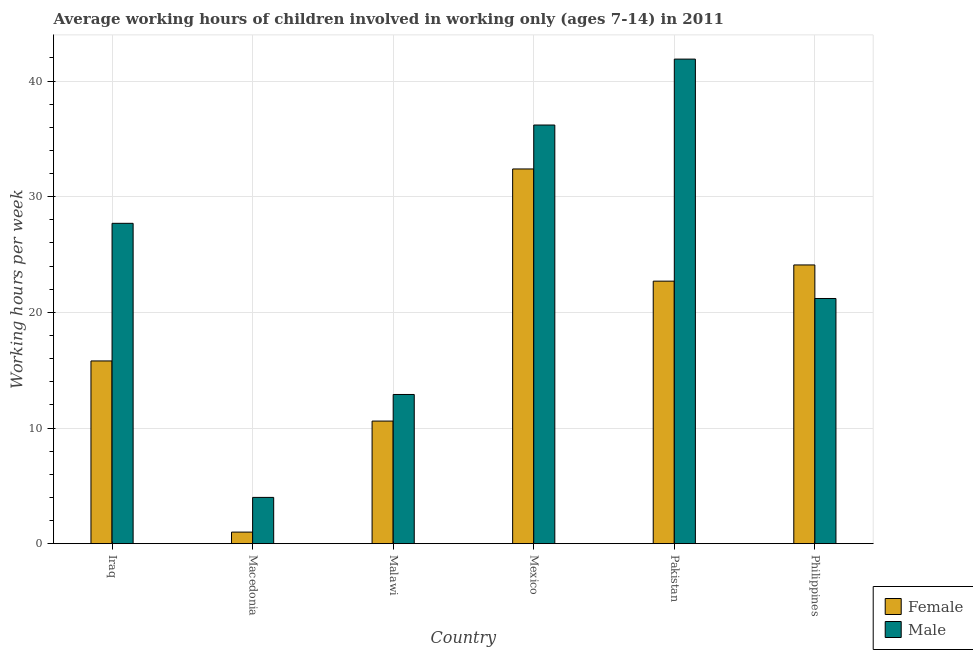How many different coloured bars are there?
Provide a short and direct response. 2. How many groups of bars are there?
Keep it short and to the point. 6. Are the number of bars per tick equal to the number of legend labels?
Your answer should be very brief. Yes. What is the label of the 3rd group of bars from the left?
Make the answer very short. Malawi. What is the average working hour of female children in Malawi?
Keep it short and to the point. 10.6. Across all countries, what is the maximum average working hour of female children?
Ensure brevity in your answer.  32.4. Across all countries, what is the minimum average working hour of male children?
Your answer should be compact. 4. In which country was the average working hour of female children minimum?
Offer a very short reply. Macedonia. What is the total average working hour of female children in the graph?
Give a very brief answer. 106.6. What is the difference between the average working hour of male children in Iraq and that in Philippines?
Offer a terse response. 6.5. What is the difference between the average working hour of male children in Malawi and the average working hour of female children in Iraq?
Your answer should be compact. -2.9. What is the average average working hour of male children per country?
Offer a very short reply. 23.98. What is the difference between the average working hour of male children and average working hour of female children in Philippines?
Provide a short and direct response. -2.9. In how many countries, is the average working hour of female children greater than 20 hours?
Provide a succinct answer. 3. What is the ratio of the average working hour of male children in Macedonia to that in Mexico?
Ensure brevity in your answer.  0.11. Is the average working hour of female children in Mexico less than that in Pakistan?
Keep it short and to the point. No. What is the difference between the highest and the second highest average working hour of female children?
Provide a short and direct response. 8.3. What is the difference between the highest and the lowest average working hour of male children?
Offer a very short reply. 37.9. Is the sum of the average working hour of female children in Iraq and Philippines greater than the maximum average working hour of male children across all countries?
Make the answer very short. No. What does the 2nd bar from the left in Pakistan represents?
Make the answer very short. Male. What does the 1st bar from the right in Iraq represents?
Offer a very short reply. Male. How many bars are there?
Your answer should be very brief. 12. How many countries are there in the graph?
Your response must be concise. 6. What is the difference between two consecutive major ticks on the Y-axis?
Provide a succinct answer. 10. Does the graph contain any zero values?
Your response must be concise. No. Where does the legend appear in the graph?
Your answer should be compact. Bottom right. How are the legend labels stacked?
Offer a very short reply. Vertical. What is the title of the graph?
Your answer should be compact. Average working hours of children involved in working only (ages 7-14) in 2011. What is the label or title of the X-axis?
Provide a succinct answer. Country. What is the label or title of the Y-axis?
Your answer should be compact. Working hours per week. What is the Working hours per week of Male in Iraq?
Provide a short and direct response. 27.7. What is the Working hours per week of Female in Macedonia?
Make the answer very short. 1. What is the Working hours per week in Male in Macedonia?
Provide a short and direct response. 4. What is the Working hours per week of Female in Malawi?
Your answer should be very brief. 10.6. What is the Working hours per week in Female in Mexico?
Ensure brevity in your answer.  32.4. What is the Working hours per week of Male in Mexico?
Your answer should be compact. 36.2. What is the Working hours per week in Female in Pakistan?
Offer a very short reply. 22.7. What is the Working hours per week of Male in Pakistan?
Your answer should be very brief. 41.9. What is the Working hours per week of Female in Philippines?
Offer a terse response. 24.1. What is the Working hours per week of Male in Philippines?
Your response must be concise. 21.2. Across all countries, what is the maximum Working hours per week in Female?
Offer a very short reply. 32.4. Across all countries, what is the maximum Working hours per week of Male?
Provide a succinct answer. 41.9. Across all countries, what is the minimum Working hours per week in Female?
Make the answer very short. 1. Across all countries, what is the minimum Working hours per week in Male?
Keep it short and to the point. 4. What is the total Working hours per week of Female in the graph?
Provide a short and direct response. 106.6. What is the total Working hours per week of Male in the graph?
Give a very brief answer. 143.9. What is the difference between the Working hours per week in Female in Iraq and that in Macedonia?
Provide a short and direct response. 14.8. What is the difference between the Working hours per week in Male in Iraq and that in Macedonia?
Make the answer very short. 23.7. What is the difference between the Working hours per week of Female in Iraq and that in Malawi?
Give a very brief answer. 5.2. What is the difference between the Working hours per week of Female in Iraq and that in Mexico?
Offer a terse response. -16.6. What is the difference between the Working hours per week in Female in Iraq and that in Pakistan?
Provide a short and direct response. -6.9. What is the difference between the Working hours per week of Male in Iraq and that in Philippines?
Your response must be concise. 6.5. What is the difference between the Working hours per week of Female in Macedonia and that in Malawi?
Provide a short and direct response. -9.6. What is the difference between the Working hours per week in Female in Macedonia and that in Mexico?
Your answer should be compact. -31.4. What is the difference between the Working hours per week of Male in Macedonia and that in Mexico?
Provide a short and direct response. -32.2. What is the difference between the Working hours per week of Female in Macedonia and that in Pakistan?
Give a very brief answer. -21.7. What is the difference between the Working hours per week of Male in Macedonia and that in Pakistan?
Make the answer very short. -37.9. What is the difference between the Working hours per week of Female in Macedonia and that in Philippines?
Offer a very short reply. -23.1. What is the difference between the Working hours per week of Male in Macedonia and that in Philippines?
Offer a very short reply. -17.2. What is the difference between the Working hours per week of Female in Malawi and that in Mexico?
Give a very brief answer. -21.8. What is the difference between the Working hours per week of Male in Malawi and that in Mexico?
Keep it short and to the point. -23.3. What is the difference between the Working hours per week of Female in Malawi and that in Pakistan?
Your answer should be very brief. -12.1. What is the difference between the Working hours per week of Male in Malawi and that in Pakistan?
Ensure brevity in your answer.  -29. What is the difference between the Working hours per week in Female in Malawi and that in Philippines?
Keep it short and to the point. -13.5. What is the difference between the Working hours per week of Female in Mexico and that in Philippines?
Your answer should be compact. 8.3. What is the difference between the Working hours per week of Female in Pakistan and that in Philippines?
Your answer should be compact. -1.4. What is the difference between the Working hours per week of Male in Pakistan and that in Philippines?
Offer a very short reply. 20.7. What is the difference between the Working hours per week of Female in Iraq and the Working hours per week of Male in Malawi?
Make the answer very short. 2.9. What is the difference between the Working hours per week of Female in Iraq and the Working hours per week of Male in Mexico?
Your answer should be compact. -20.4. What is the difference between the Working hours per week in Female in Iraq and the Working hours per week in Male in Pakistan?
Offer a terse response. -26.1. What is the difference between the Working hours per week of Female in Macedonia and the Working hours per week of Male in Mexico?
Give a very brief answer. -35.2. What is the difference between the Working hours per week in Female in Macedonia and the Working hours per week in Male in Pakistan?
Your answer should be very brief. -40.9. What is the difference between the Working hours per week in Female in Macedonia and the Working hours per week in Male in Philippines?
Ensure brevity in your answer.  -20.2. What is the difference between the Working hours per week of Female in Malawi and the Working hours per week of Male in Mexico?
Your response must be concise. -25.6. What is the difference between the Working hours per week in Female in Malawi and the Working hours per week in Male in Pakistan?
Provide a short and direct response. -31.3. What is the difference between the Working hours per week of Female in Malawi and the Working hours per week of Male in Philippines?
Offer a very short reply. -10.6. What is the difference between the Working hours per week in Female in Mexico and the Working hours per week in Male in Pakistan?
Provide a succinct answer. -9.5. What is the average Working hours per week of Female per country?
Make the answer very short. 17.77. What is the average Working hours per week in Male per country?
Offer a very short reply. 23.98. What is the difference between the Working hours per week in Female and Working hours per week in Male in Iraq?
Provide a succinct answer. -11.9. What is the difference between the Working hours per week of Female and Working hours per week of Male in Malawi?
Provide a short and direct response. -2.3. What is the difference between the Working hours per week of Female and Working hours per week of Male in Pakistan?
Offer a terse response. -19.2. What is the ratio of the Working hours per week of Female in Iraq to that in Macedonia?
Provide a short and direct response. 15.8. What is the ratio of the Working hours per week of Male in Iraq to that in Macedonia?
Make the answer very short. 6.92. What is the ratio of the Working hours per week of Female in Iraq to that in Malawi?
Provide a short and direct response. 1.49. What is the ratio of the Working hours per week in Male in Iraq to that in Malawi?
Give a very brief answer. 2.15. What is the ratio of the Working hours per week of Female in Iraq to that in Mexico?
Make the answer very short. 0.49. What is the ratio of the Working hours per week of Male in Iraq to that in Mexico?
Keep it short and to the point. 0.77. What is the ratio of the Working hours per week in Female in Iraq to that in Pakistan?
Provide a succinct answer. 0.7. What is the ratio of the Working hours per week of Male in Iraq to that in Pakistan?
Your answer should be very brief. 0.66. What is the ratio of the Working hours per week of Female in Iraq to that in Philippines?
Make the answer very short. 0.66. What is the ratio of the Working hours per week of Male in Iraq to that in Philippines?
Give a very brief answer. 1.31. What is the ratio of the Working hours per week in Female in Macedonia to that in Malawi?
Keep it short and to the point. 0.09. What is the ratio of the Working hours per week in Male in Macedonia to that in Malawi?
Your answer should be very brief. 0.31. What is the ratio of the Working hours per week of Female in Macedonia to that in Mexico?
Give a very brief answer. 0.03. What is the ratio of the Working hours per week of Male in Macedonia to that in Mexico?
Provide a succinct answer. 0.11. What is the ratio of the Working hours per week in Female in Macedonia to that in Pakistan?
Make the answer very short. 0.04. What is the ratio of the Working hours per week of Male in Macedonia to that in Pakistan?
Your answer should be compact. 0.1. What is the ratio of the Working hours per week in Female in Macedonia to that in Philippines?
Your answer should be compact. 0.04. What is the ratio of the Working hours per week of Male in Macedonia to that in Philippines?
Your response must be concise. 0.19. What is the ratio of the Working hours per week of Female in Malawi to that in Mexico?
Provide a succinct answer. 0.33. What is the ratio of the Working hours per week in Male in Malawi to that in Mexico?
Provide a succinct answer. 0.36. What is the ratio of the Working hours per week in Female in Malawi to that in Pakistan?
Your answer should be very brief. 0.47. What is the ratio of the Working hours per week of Male in Malawi to that in Pakistan?
Make the answer very short. 0.31. What is the ratio of the Working hours per week in Female in Malawi to that in Philippines?
Ensure brevity in your answer.  0.44. What is the ratio of the Working hours per week of Male in Malawi to that in Philippines?
Ensure brevity in your answer.  0.61. What is the ratio of the Working hours per week in Female in Mexico to that in Pakistan?
Provide a short and direct response. 1.43. What is the ratio of the Working hours per week of Male in Mexico to that in Pakistan?
Your answer should be compact. 0.86. What is the ratio of the Working hours per week in Female in Mexico to that in Philippines?
Make the answer very short. 1.34. What is the ratio of the Working hours per week of Male in Mexico to that in Philippines?
Provide a short and direct response. 1.71. What is the ratio of the Working hours per week of Female in Pakistan to that in Philippines?
Offer a very short reply. 0.94. What is the ratio of the Working hours per week in Male in Pakistan to that in Philippines?
Provide a short and direct response. 1.98. What is the difference between the highest and the second highest Working hours per week of Female?
Give a very brief answer. 8.3. What is the difference between the highest and the lowest Working hours per week in Female?
Your answer should be very brief. 31.4. What is the difference between the highest and the lowest Working hours per week in Male?
Offer a very short reply. 37.9. 